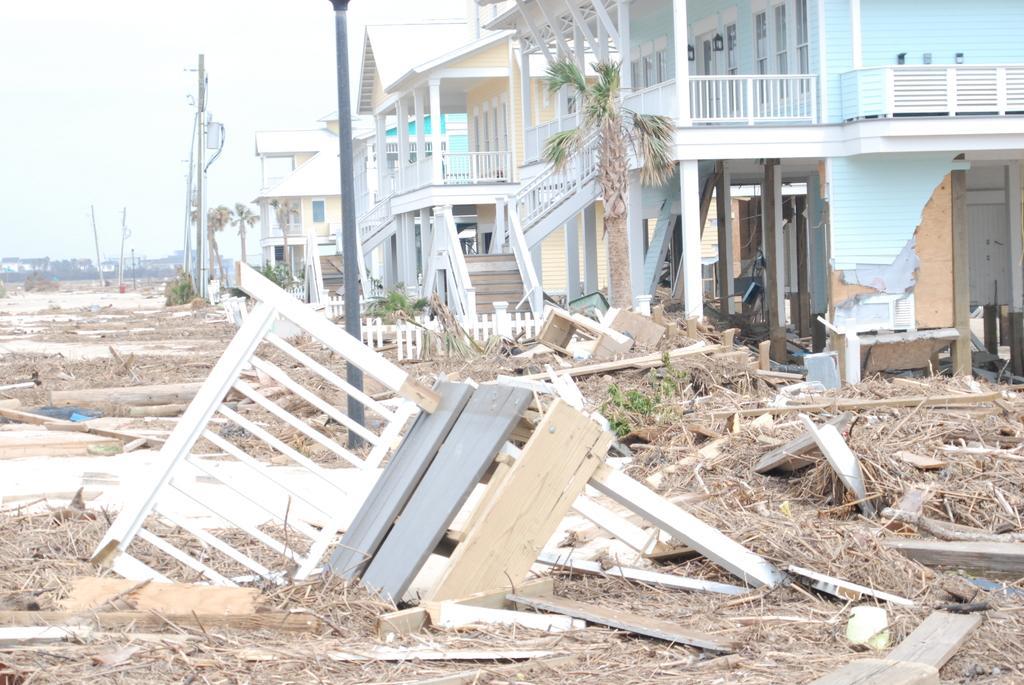Describe this image in one or two sentences. In this picture we can see wooden objects and sticks on the ground, poles, buildings, trees and some objects and in the background we can see the sky. 